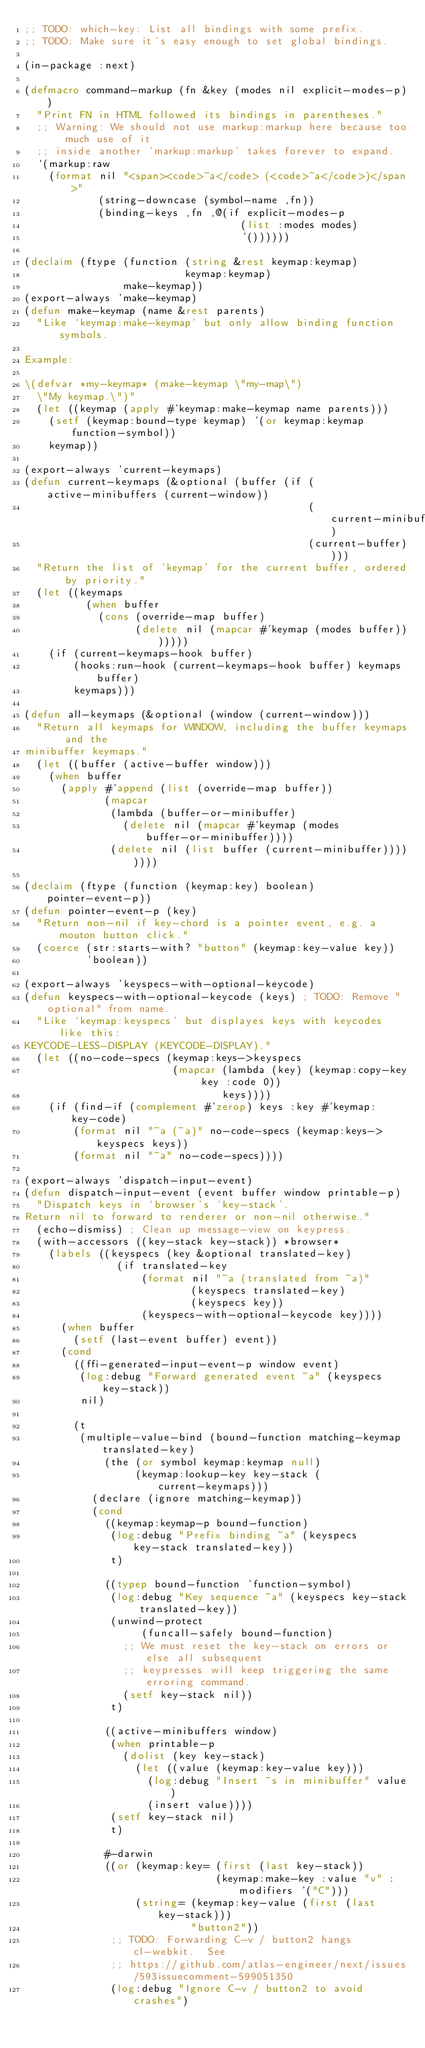Convert code to text. <code><loc_0><loc_0><loc_500><loc_500><_Lisp_>;; TODO: which-key: List all bindings with some prefix.
;; TODO: Make sure it's easy enough to set global bindings.

(in-package :next)

(defmacro command-markup (fn &key (modes nil explicit-modes-p))
  "Print FN in HTML followed its bindings in parentheses."
  ;; Warning: We should not use markup:markup here because too much use of it
  ;; inside another `markup:markup' takes forever to expand.
  `(markup:raw
    (format nil "<span><code>~a</code> (<code>~a</code>)</span>"
            (string-downcase (symbol-name ,fn))
            (binding-keys ,fn ,@(if explicit-modes-p
                                   (list :modes modes)
                                   '())))))

(declaim (ftype (function (string &rest keymap:keymap)
                          keymap:keymap)
                make-keymap))
(export-always 'make-keymap)
(defun make-keymap (name &rest parents)
  "Like `keymap:make-keymap' but only allow binding function symbols.

Example:

\(defvar *my-keymap* (make-keymap \"my-map\")
  \"My keymap.\")"
  (let ((keymap (apply #'keymap:make-keymap name parents)))
    (setf (keymap:bound-type keymap) '(or keymap:keymap function-symbol))
    keymap))

(export-always 'current-keymaps)
(defun current-keymaps (&optional (buffer (if (active-minibuffers (current-window))
                                              (current-minibuffer)
                                              (current-buffer))))
  "Return the list of `keymap' for the current buffer, ordered by priority."
  (let ((keymaps
          (when buffer
            (cons (override-map buffer)
                  (delete nil (mapcar #'keymap (modes buffer)))))))
    (if (current-keymaps-hook buffer)
        (hooks:run-hook (current-keymaps-hook buffer) keymaps buffer)
        keymaps)))

(defun all-keymaps (&optional (window (current-window)))
  "Return all keymaps for WINDOW, including the buffer keymaps and the
minibuffer keymaps."
  (let ((buffer (active-buffer window)))
    (when buffer
      (apply #'append (list (override-map buffer))
             (mapcar
              (lambda (buffer-or-minibuffer)
                (delete nil (mapcar #'keymap (modes buffer-or-minibuffer))))
              (delete nil (list buffer (current-minibuffer))))))))

(declaim (ftype (function (keymap:key) boolean) pointer-event-p))
(defun pointer-event-p (key)
  "Return non-nil if key-chord is a pointer event, e.g. a mouton button click."
  (coerce (str:starts-with? "button" (keymap:key-value key))
          'boolean))

(export-always 'keyspecs-with-optional-keycode)
(defun keyspecs-with-optional-keycode (keys) ; TODO: Remove "optional" from name.
  "Like `keymap:keyspecs' but displayes keys with keycodes like this:
KEYCODE-LESS-DISPLAY (KEYCODE-DISPLAY)."
  (let ((no-code-specs (keymap:keys->keyspecs
                        (mapcar (lambda (key) (keymap:copy-key key :code 0))
                                keys))))
    (if (find-if (complement #'zerop) keys :key #'keymap:key-code)
        (format nil "~a (~a)" no-code-specs (keymap:keys->keyspecs keys))
        (format nil "~a" no-code-specs))))

(export-always 'dispatch-input-event)
(defun dispatch-input-event (event buffer window printable-p)
  "Dispatch keys in `browser's `key-stack'.
Return nil to forward to renderer or non-nil otherwise."
  (echo-dismiss) ; Clean up message-view on keypress.
  (with-accessors ((key-stack key-stack)) *browser*
    (labels ((keyspecs (key &optional translated-key)
               (if translated-key
                   (format nil "~a (translated from ~a)"
                           (keyspecs translated-key)
                           (keyspecs key))
                   (keyspecs-with-optional-keycode key))))
      (when buffer
        (setf (last-event buffer) event))
      (cond
        ((ffi-generated-input-event-p window event)
         (log:debug "Forward generated event ~a" (keyspecs key-stack))
         nil)

        (t
         (multiple-value-bind (bound-function matching-keymap translated-key)
             (the (or symbol keymap:keymap null)
                  (keymap:lookup-key key-stack (current-keymaps)))
           (declare (ignore matching-keymap))
           (cond
             ((keymap:keymap-p bound-function)
              (log:debug "Prefix binding ~a" (keyspecs key-stack translated-key))
              t)

             ((typep bound-function 'function-symbol)
              (log:debug "Key sequence ~a" (keyspecs key-stack translated-key))
              (unwind-protect
                   (funcall-safely bound-function)
                ;; We must reset the key-stack on errors or else all subsequent
                ;; keypresses will keep triggering the same erroring command.
                (setf key-stack nil))
              t)

             ((active-minibuffers window)
              (when printable-p
                (dolist (key key-stack)
                  (let ((value (keymap:key-value key)))
                    (log:debug "Insert ~s in minibuffer" value)
                    (insert value))))
              (setf key-stack nil)
              t)

             #-darwin
             ((or (keymap:key= (first (last key-stack))
                               (keymap:make-key :value "v" :modifiers '("C")))
                  (string= (keymap:key-value (first (last key-stack)))
                           "button2"))
              ;; TODO: Forwarding C-v / button2 hangs cl-webkit.  See
              ;; https://github.com/atlas-engineer/next/issues/593issuecomment-599051350
              (log:debug "Ignore C-v / button2 to avoid crashes")</code> 